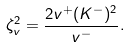<formula> <loc_0><loc_0><loc_500><loc_500>\zeta _ { v } ^ { 2 } = \frac { 2 v ^ { + } ( K ^ { - } ) ^ { 2 } } { v ^ { - } } .</formula> 